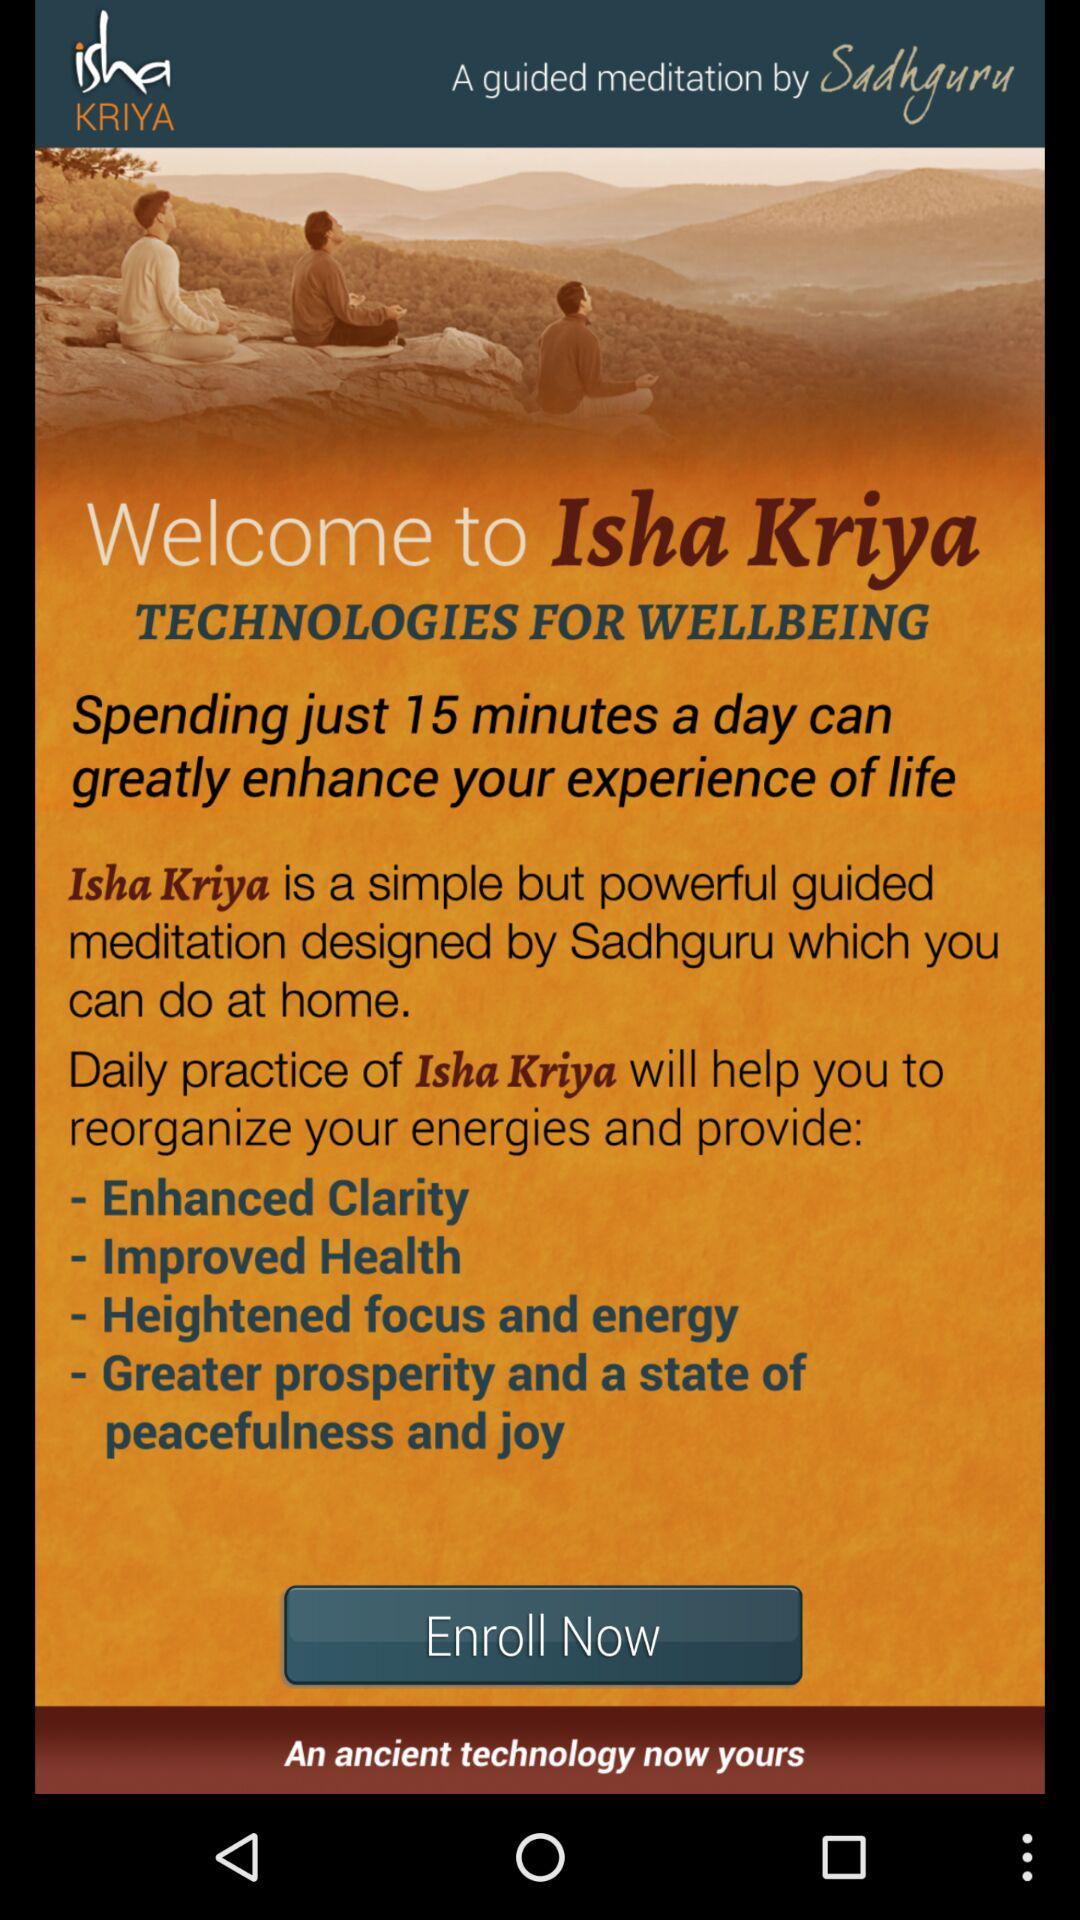Isha Kriya is designed by whom? Isha Kriya is designed by Sadhguru. 